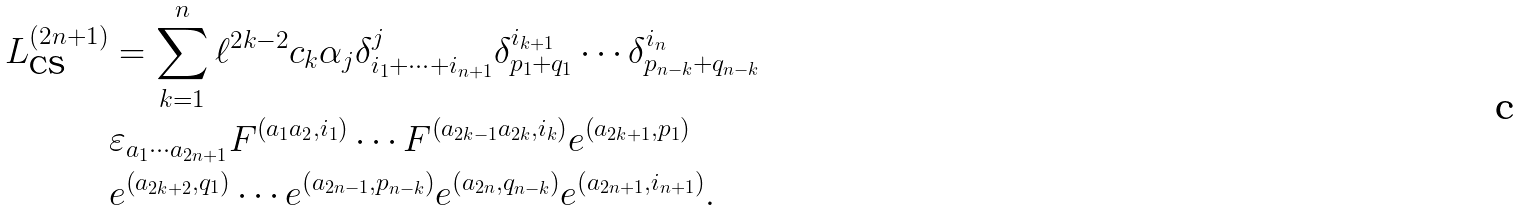<formula> <loc_0><loc_0><loc_500><loc_500>L _ { \text {CS} } ^ { \left ( 2 n + 1 \right ) } & = \sum _ { k = 1 } ^ { n } \ell ^ { 2 k - 2 } c _ { k } \alpha _ { j } \delta _ { i _ { 1 } + \cdots + i _ { n + 1 } } ^ { j } \delta _ { p _ { 1 } + q _ { 1 } } ^ { i _ { k + 1 } } \cdots \delta _ { p _ { n - k } + q _ { n - k } } ^ { i _ { n } } \\ & \varepsilon _ { a _ { 1 } \cdots a _ { 2 n + 1 } } F ^ { \left ( a _ { 1 } a _ { 2 } , i _ { 1 } \right ) } \cdots F ^ { \left ( a _ { 2 k - 1 } a _ { 2 k } , i _ { k } \right ) } e ^ { \left ( a _ { 2 k + 1 } , p _ { 1 } \right ) } \\ & e ^ { \left ( a _ { 2 k + 2 } , q _ { 1 } \right ) } \cdots e ^ { \left ( a _ { 2 n - 1 } , p _ { n - k } \right ) } e ^ { \left ( a _ { 2 n } , q _ { n - k } \right ) } e ^ { \left ( a _ { 2 n + 1 } , i _ { n + 1 } \right ) } .</formula> 